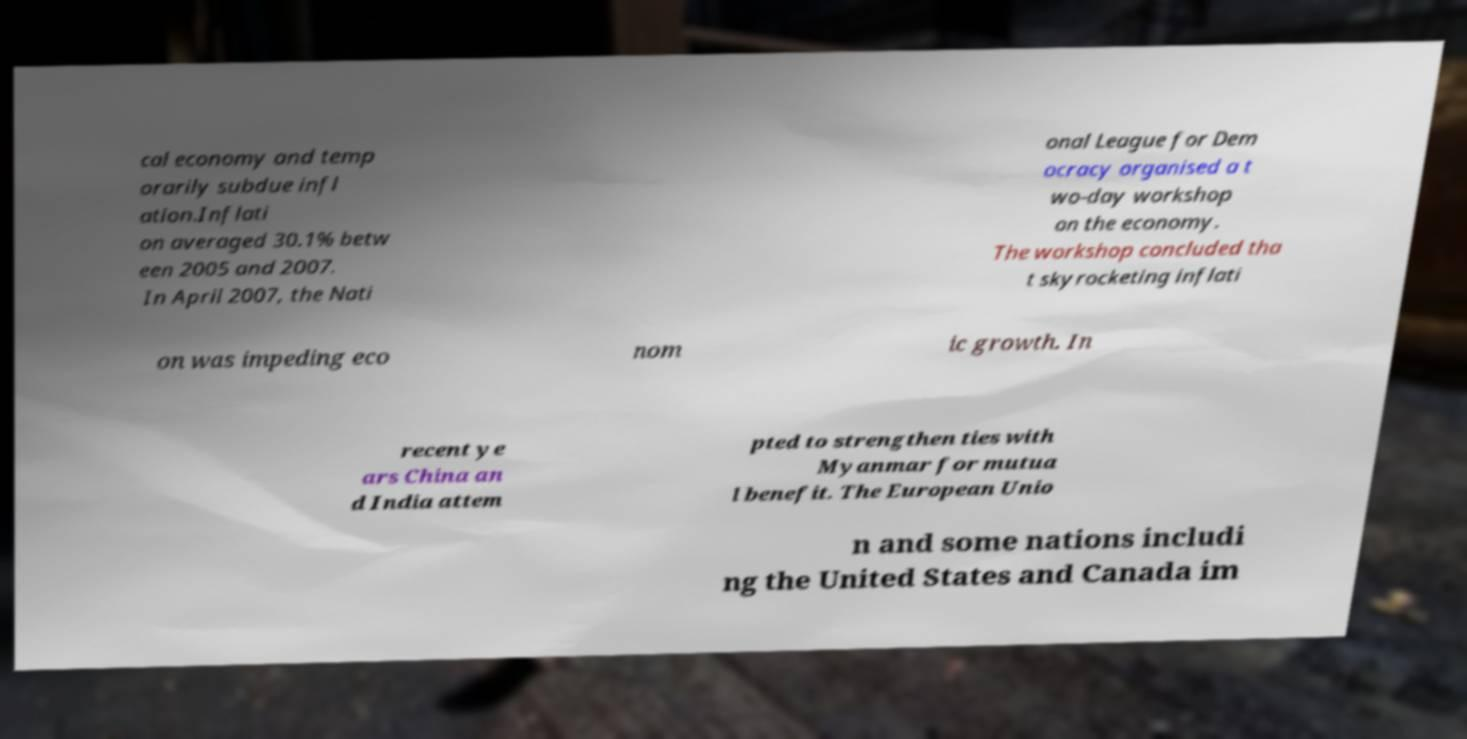Could you extract and type out the text from this image? cal economy and temp orarily subdue infl ation.Inflati on averaged 30.1% betw een 2005 and 2007. In April 2007, the Nati onal League for Dem ocracy organised a t wo-day workshop on the economy. The workshop concluded tha t skyrocketing inflati on was impeding eco nom ic growth. In recent ye ars China an d India attem pted to strengthen ties with Myanmar for mutua l benefit. The European Unio n and some nations includi ng the United States and Canada im 